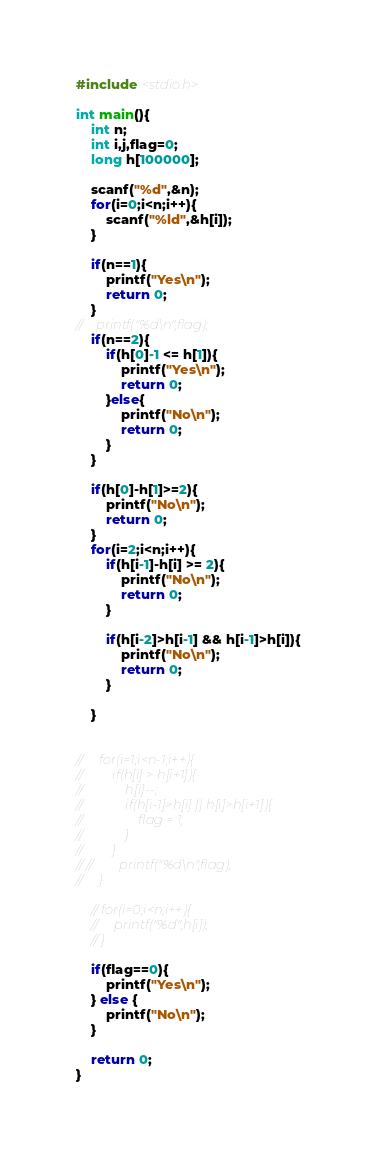<code> <loc_0><loc_0><loc_500><loc_500><_C_>#include <stdio.h>

int main(){
    int n;
    int i,j,flag=0;
    long h[100000];

    scanf("%d",&n);
    for(i=0;i<n;i++){
        scanf("%ld",&h[i]);
    }

    if(n==1){
        printf("Yes\n");
        return 0;
    }
//    printf("%d\n",flag);
    if(n==2){
        if(h[0]-1 <= h[1]){
            printf("Yes\n");
            return 0;
        }else{
            printf("No\n");
            return 0;
        }
    }

    if(h[0]-h[1]>=2){
        printf("No\n");
        return 0;
    }
    for(i=2;i<n;i++){
        if(h[i-1]-h[i] >= 2){
            printf("No\n");
            return 0;
        }

        if(h[i-2]>h[i-1] && h[i-1]>h[i]){
            printf("No\n");
            return 0;
        }

    }


//     for(i=1;i<n-1;i++){
//         if(h[i] > h[i+1]){
//             h[i]--;
//             if(h[i-1]>h[i] || h[i]>h[i+1]){
//                 flag = 1;
//             }
//         }
// //        printf("%d\n",flag);
//     }

    // for(i=0;i<n;i++){
    //     printf("%d",h[i]);
    // }

    if(flag==0){
        printf("Yes\n");
    } else {
        printf("No\n");
    }

    return 0;
}</code> 